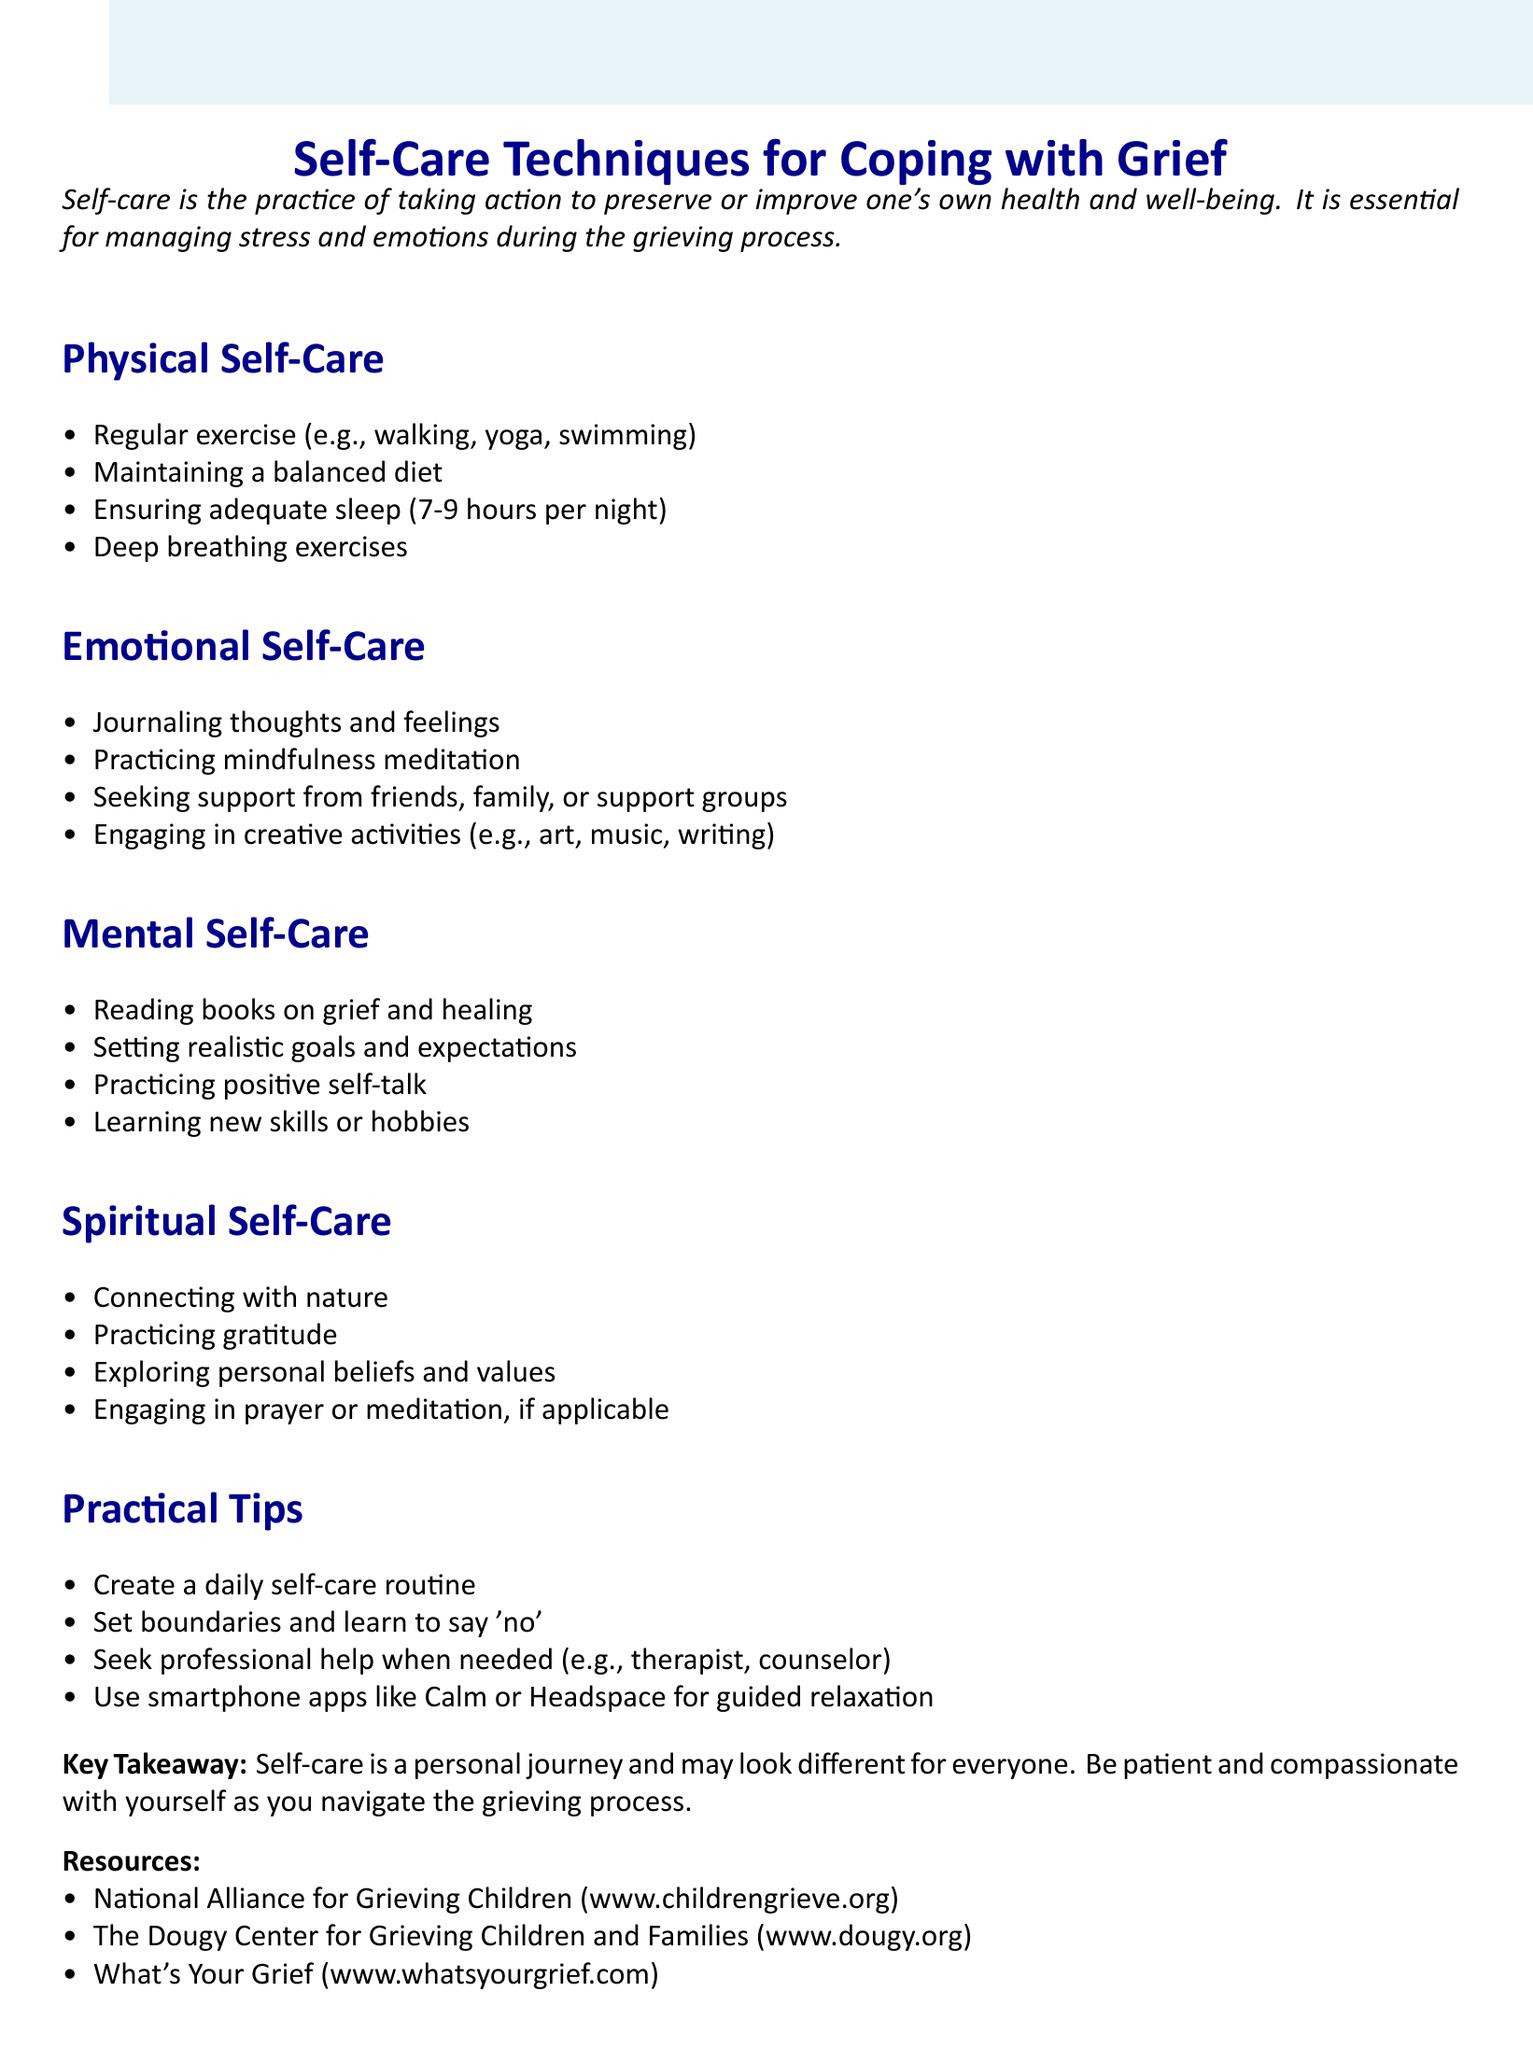What is the workshop title? The workshop title is explicitly stated in the document, which is "Self-Care Techniques for Coping with Grief."
Answer: Self-Care Techniques for Coping with Grief What is one example of physical self-care? The document lists several examples of physical self-care, such as "Regular exercise (e.g., walking, yoga, swimming)."
Answer: Regular exercise (e.g., walking, yoga, swimming) How many hours of sleep are recommended? The document mentions that adequate sleep is 7-9 hours per night.
Answer: 7-9 hours What is a key takeaway from the workshop? The document concludes with a key takeaway about self-care being a personal journey.
Answer: Self-care is a personal journey and may look different for everyone What type of self-care includes mindfulness meditation? The document classifies mindfulness meditation under emotional self-care techniques.
Answer: Emotional Self-Care Name one resource mentioned in the document. The document lists several resources, such as "National Alliance for Grieving Children."
Answer: National Alliance for Grieving Children Which activity is suggested for spiritual self-care? The document suggests connecting with nature as one of the activities for spiritual self-care.
Answer: Connecting with nature What is one practical tip for self-care? One of the practical tips listed in the document is to "Create a daily self-care routine."
Answer: Create a daily self-care routine Who should be sought for professional support if needed? The document indicates that individuals should seek professional help from a therapist or counselor when needed.
Answer: Therapist or counselor 